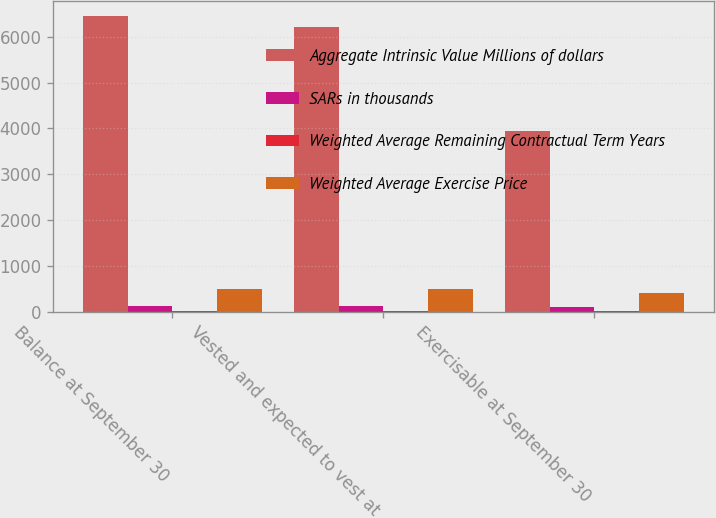Convert chart to OTSL. <chart><loc_0><loc_0><loc_500><loc_500><stacked_bar_chart><ecel><fcel>Balance at September 30<fcel>Vested and expected to vest at<fcel>Exercisable at September 30<nl><fcel>Aggregate Intrinsic Value Millions of dollars<fcel>6466<fcel>6215<fcel>3952<nl><fcel>SARs in thousands<fcel>117.94<fcel>116.54<fcel>96<nl><fcel>Weighted Average Remaining Contractual Term Years<fcel>6.24<fcel>6.16<fcel>4.98<nl><fcel>Weighted Average Exercise Price<fcel>504<fcel>493<fcel>395<nl></chart> 